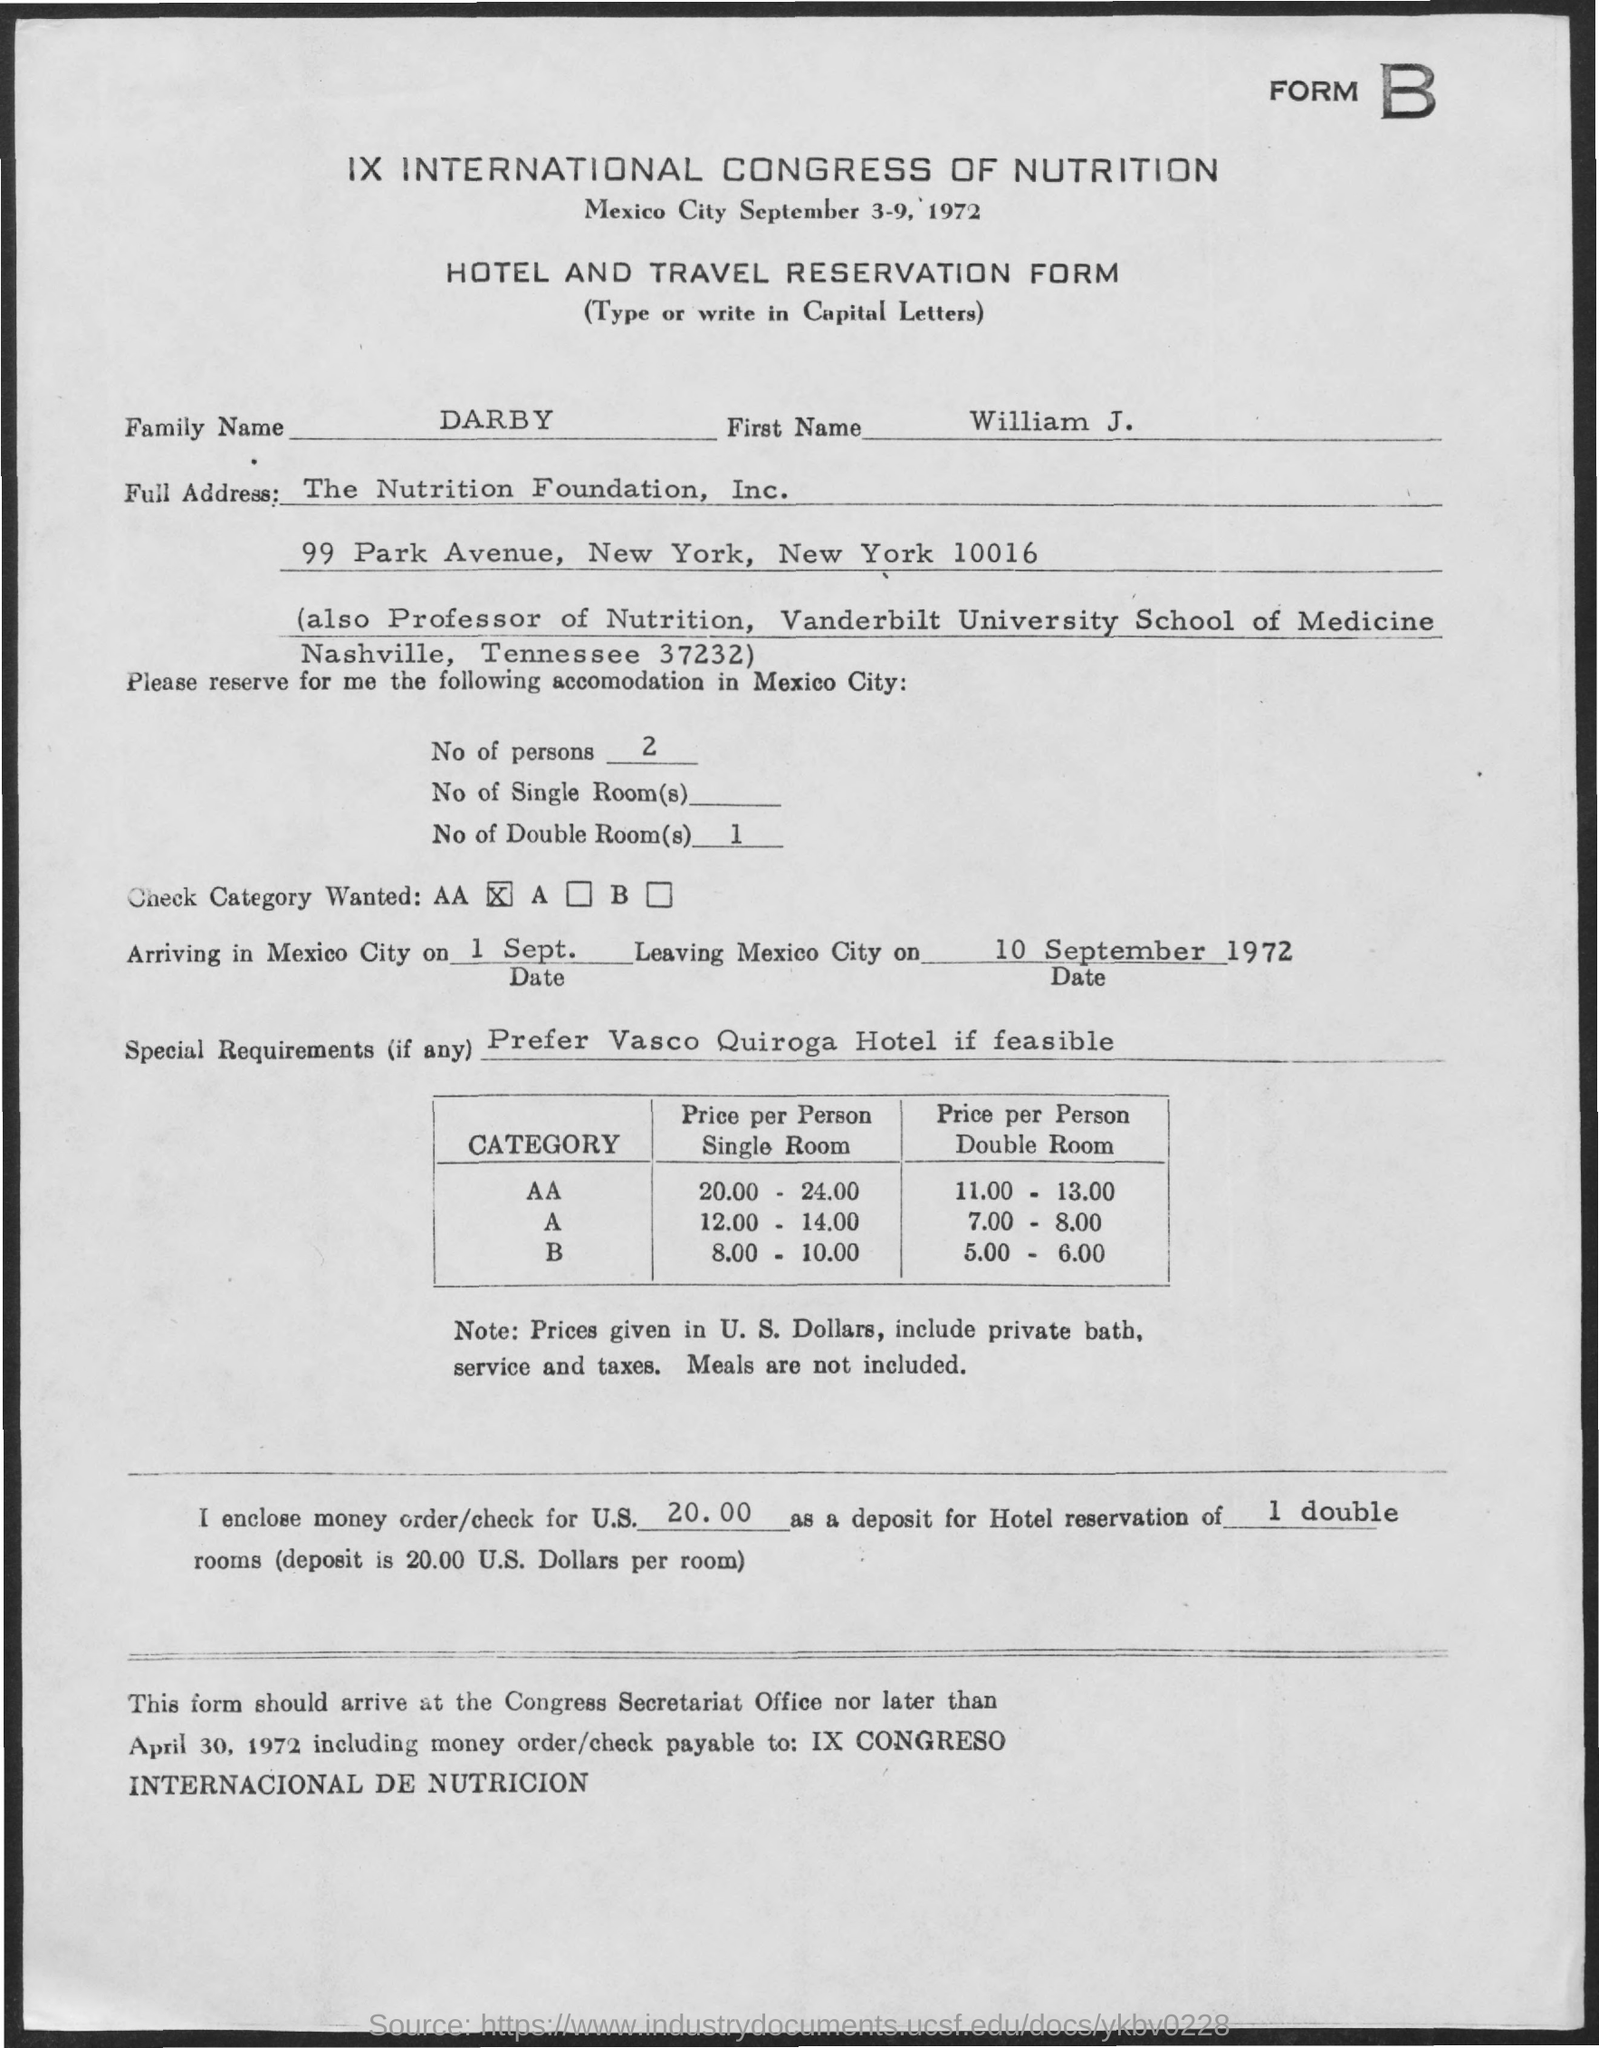Point out several critical features in this image. The first name is William J. The family name is Darby. 